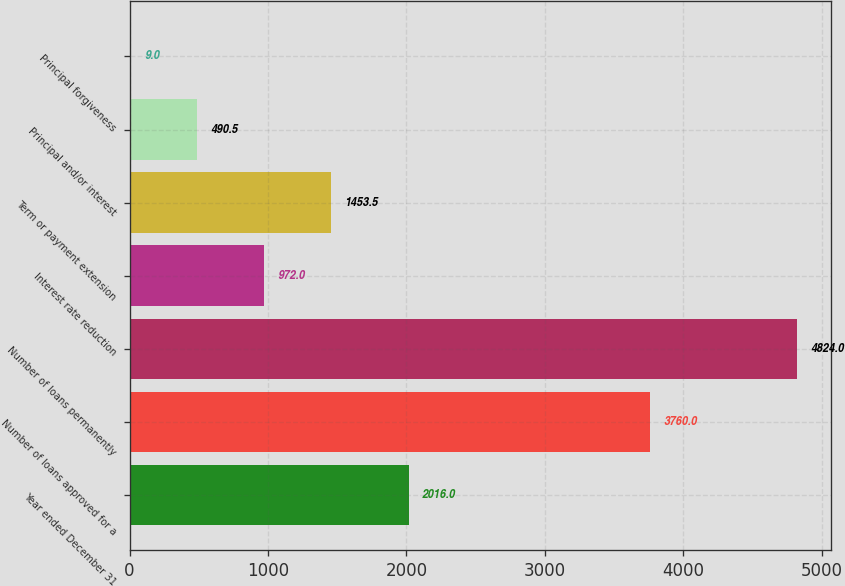Convert chart to OTSL. <chart><loc_0><loc_0><loc_500><loc_500><bar_chart><fcel>Year ended December 31<fcel>Number of loans approved for a<fcel>Number of loans permanently<fcel>Interest rate reduction<fcel>Term or payment extension<fcel>Principal and/or interest<fcel>Principal forgiveness<nl><fcel>2016<fcel>3760<fcel>4824<fcel>972<fcel>1453.5<fcel>490.5<fcel>9<nl></chart> 